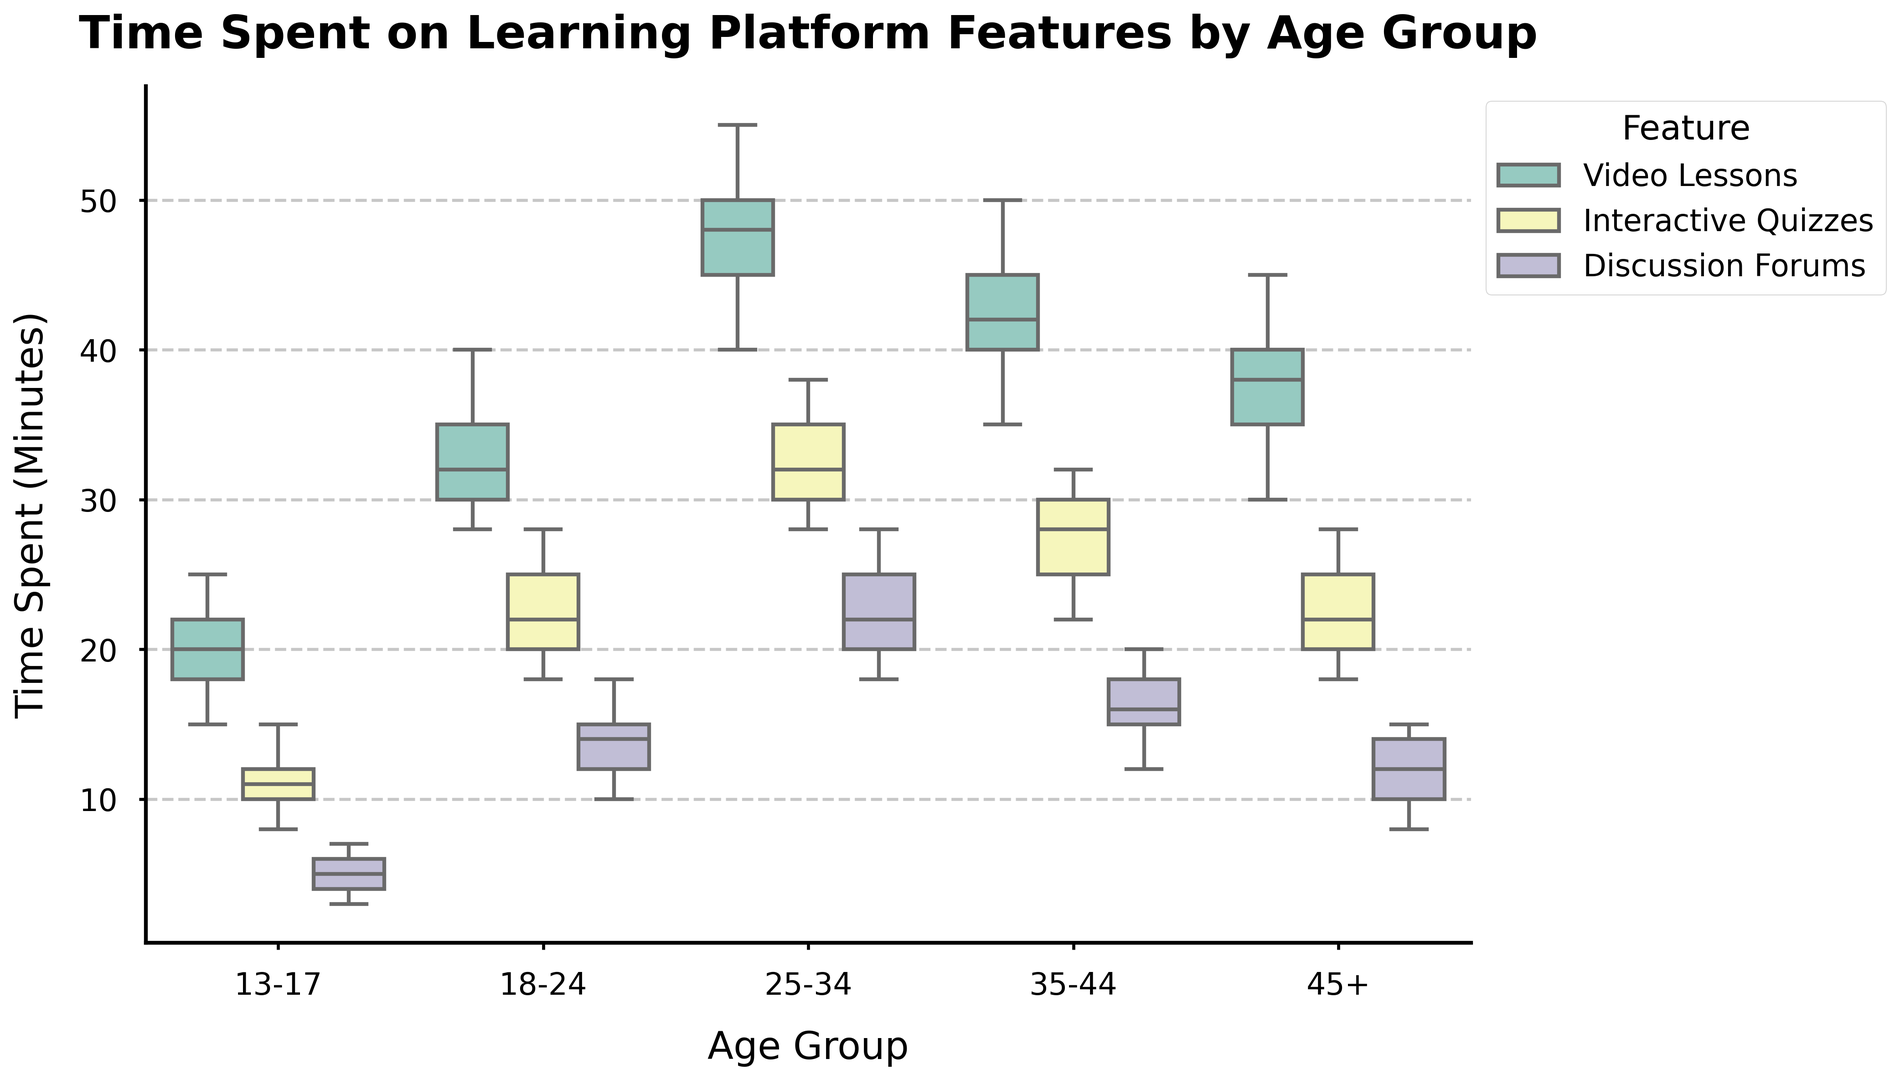What is the median time spent on Video Lessons by the 18-24 age group? The box plot shows the central line within the box represents the median value. For the 18-24 age group under Video Lessons, the median value represented by the central line in the box plot can be identified.
Answer: 32 Which age group spends the least amount of time on Discussion Forums? By looking at the box plots for the Discussion Forums feature, the lowest adjacent value (whisker) can be compared across different age groups. The 13-17 age group has the lowest minimum value (3 minutes).
Answer: 13-17 How does the interquartile range (IQR) of time spent on Interactive Quizzes in the 25-34 age group compare to the 35-44 age group? The IQR is visualized by the height of the box in the box plot. For the 25-34 age group, the IQR is the range from the first quartile (Q1) to the third quartile (Q3). Similarly, observe this range for the 35-44 age group and compare the two ranges.
Answer: The IQR for 25-34 is larger than 35-44 Which feature shows the greatest variance in time spent for the 45+ age group? Variance in time spent can be visually assessed by observing the height of the box plots and the length of the whiskers. The feature with the largest box and whiskers indicates the greatest variance.
Answer: Video Lessons What is the difference in median time spent on Interactive Quizzes between the 13-17 and 18-24 age groups? Identify the median values (central line in the box) for Interactive Quizzes for both age groups and calculate their difference. Median for 13-17 is 11 and for 18-24 is 22. Difference is
Answer: 11 Which age group has the longest upper whisker for time spent on Video Lessons? The upper whisker indicates the maximum time excluding outliers. Compare the lengths of the upper whiskers for Video Lessons across all age groups.
Answer: 25-34 By how many minutes does the median time spent on Discussion Forums increase from the 13-17 age group to the 18-24 age group? Identify the median value for Discussion Forums for both age groups from the box plots and subtract the 13-17 median from the 18-24 median. Median for 13-17 is 5, and for 18-24 it is 14. The increase is
Answer: 9 Which feature has the narrowest IQR across all age groups? Identify which feature has the smallest height of the box (distance between Q1 and Q3) consistently across all age groups. By looking at the box plots, it's evident that Discussion Forums have relatively narrow boxes compared to other features.
Answer: Discussion Forums What is the overall trend in time spent on Interactive Quizzes across age groups? Examine the median values of the Interactive Quizzes box plots from the youngest to the oldest age groups and describe the trend.
Answer: Increasing trend Between which age groups is the interquartile range (IQR) for Video Lessons the largest? Calculate the IQR (Q3 - Q1) for Video Lessons for each age group, then determine which age group's difference is the largest. The age groups with the largest IQR for Video Lessons can be identified as the ones with the widest box.
Answer: 25-34 